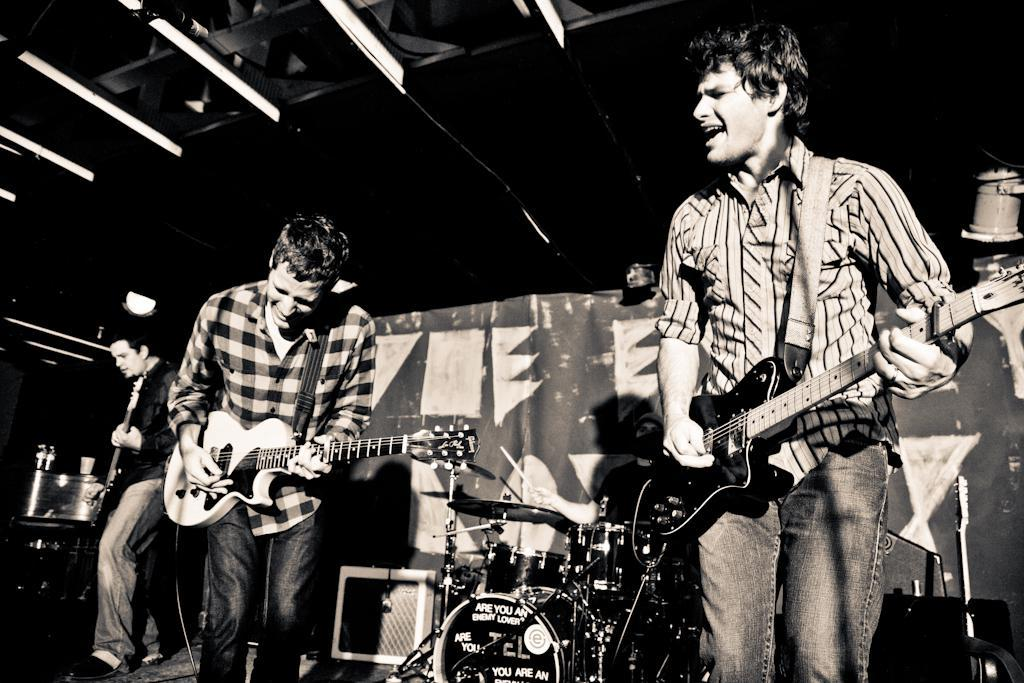What are the people in the image doing? The people in the image are playing musical instruments. What can be seen in the background of the image? There is a banner in the background. What else is visible in the image besides the people and the banner? There are lights visible in the image. How is the distribution of the kite managed in the image? There is no kite present in the image, so the distribution cannot be determined. What song is being played by the people in the image? The image does not provide information about the specific song being played by the people. 